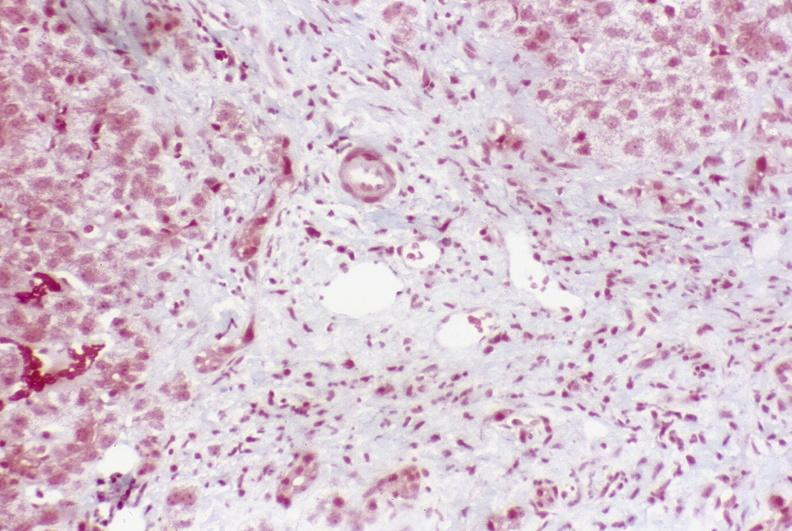what is present?
Answer the question using a single word or phrase. Hepatobiliary 